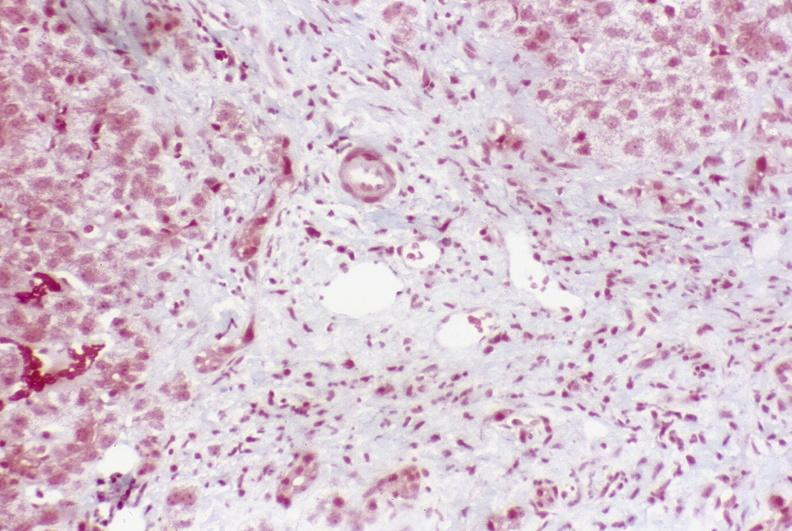what is present?
Answer the question using a single word or phrase. Hepatobiliary 